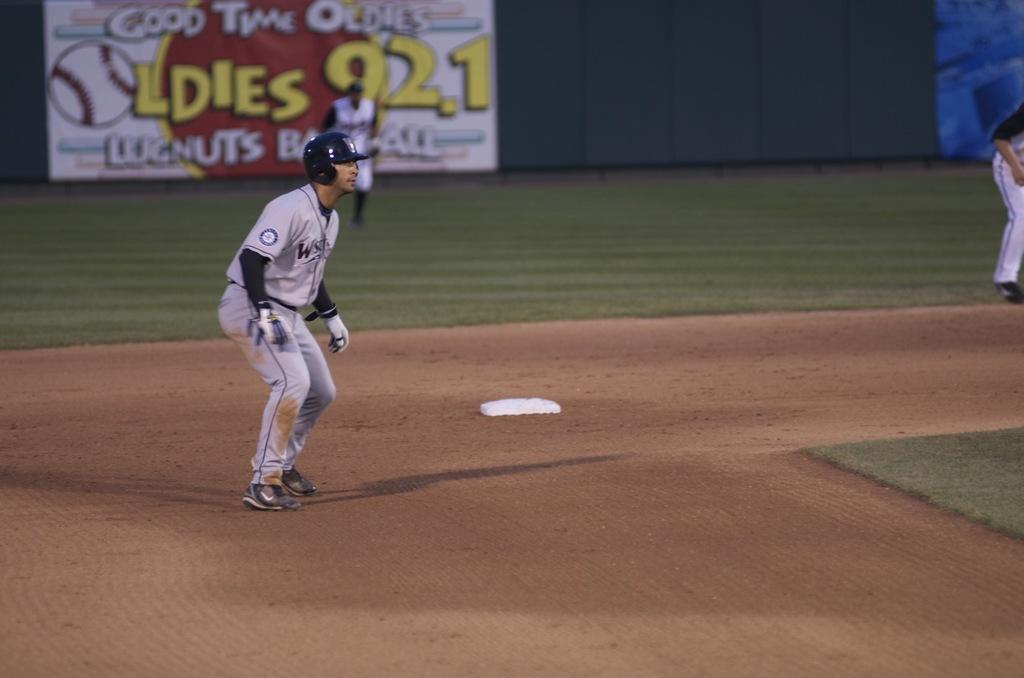<image>
Provide a brief description of the given image. a baseball player getting ready to run, a sign of Oldies 92.1 behind him 